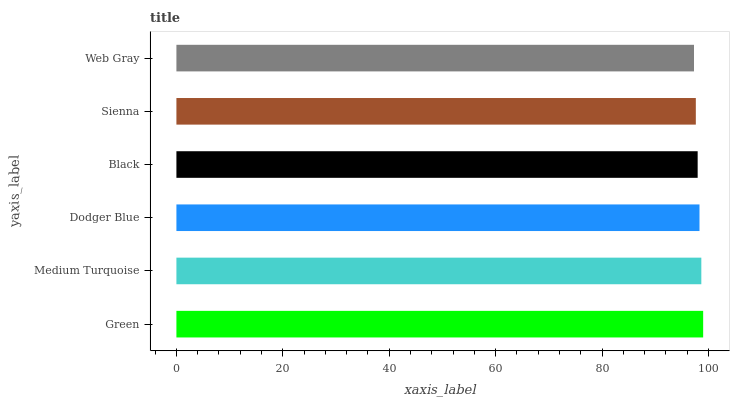Is Web Gray the minimum?
Answer yes or no. Yes. Is Green the maximum?
Answer yes or no. Yes. Is Medium Turquoise the minimum?
Answer yes or no. No. Is Medium Turquoise the maximum?
Answer yes or no. No. Is Green greater than Medium Turquoise?
Answer yes or no. Yes. Is Medium Turquoise less than Green?
Answer yes or no. Yes. Is Medium Turquoise greater than Green?
Answer yes or no. No. Is Green less than Medium Turquoise?
Answer yes or no. No. Is Dodger Blue the high median?
Answer yes or no. Yes. Is Black the low median?
Answer yes or no. Yes. Is Medium Turquoise the high median?
Answer yes or no. No. Is Medium Turquoise the low median?
Answer yes or no. No. 